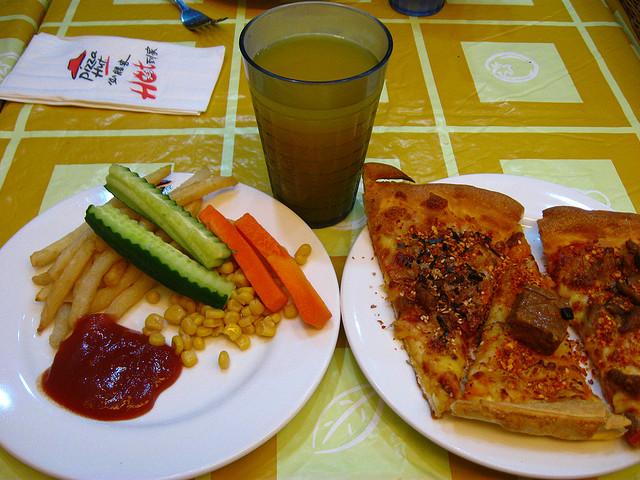What type of drink is that?
Concise answer only. Juice. What is printed on the napkin?
Give a very brief answer. Pizza hut. Are these leftovers?
Give a very brief answer. No. Is there ketchup on the food?
Be succinct. Yes. What are the people drinking?
Be succinct. Orange juice. What two colors are the tablecloth?
Be succinct. Yellow and white. What is in the glasses?
Concise answer only. Juice. Would the food on the plate on the left be considered the entree?
Give a very brief answer. No. What vegetables are on the plate?
Concise answer only. Carrot zucchini potato corn. Is this meal vegetarian?
Quick response, please. No. How many slices of pizza is there?
Give a very brief answer. 3. What brand of soda is the background?
Give a very brief answer. No soda. Is there a straw in the photo?
Quick response, please. No. What restaurant is this at?
Concise answer only. Pizza hut. 